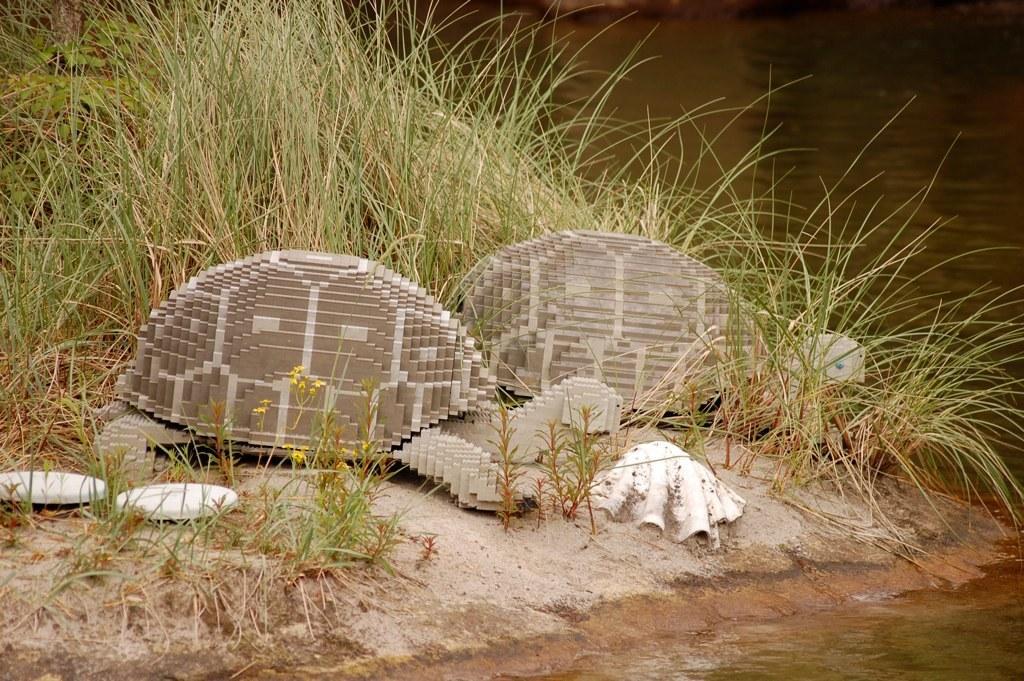Could you give a brief overview of what you see in this image? In this picture we can see the grass, shell, tortoise toys and some objects on the ground and in the background we can see the water. 